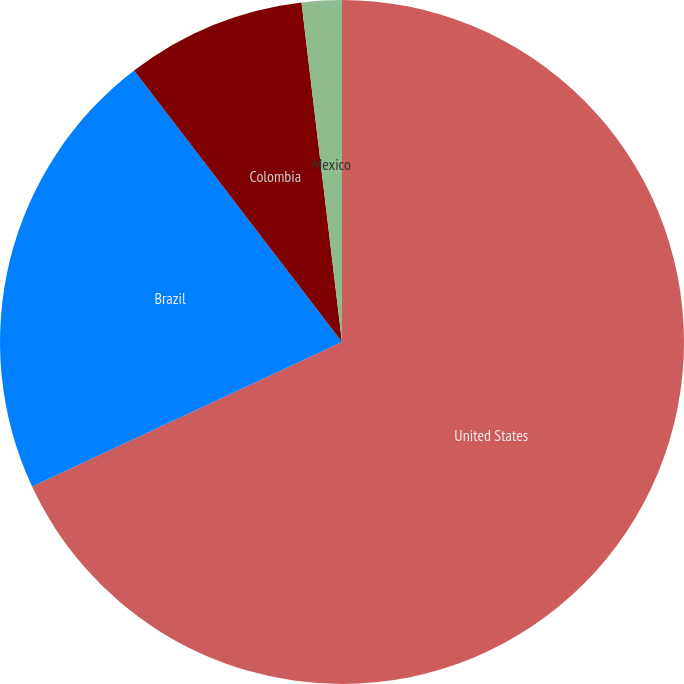<chart> <loc_0><loc_0><loc_500><loc_500><pie_chart><fcel>United States<fcel>Brazil<fcel>Colombia<fcel>Mexico<nl><fcel>68.06%<fcel>21.55%<fcel>8.51%<fcel>1.89%<nl></chart> 